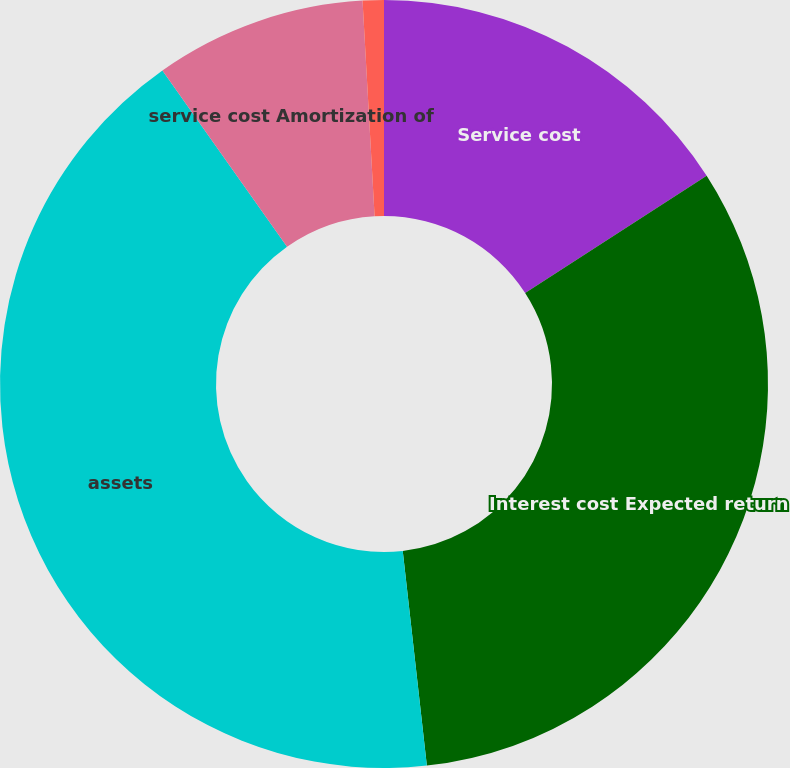Convert chart. <chart><loc_0><loc_0><loc_500><loc_500><pie_chart><fcel>Service cost<fcel>Interest cost Expected return<fcel>assets<fcel>service cost Amortization of<fcel>Cost (income) of settlement/<nl><fcel>15.88%<fcel>32.34%<fcel>41.99%<fcel>8.9%<fcel>0.89%<nl></chart> 